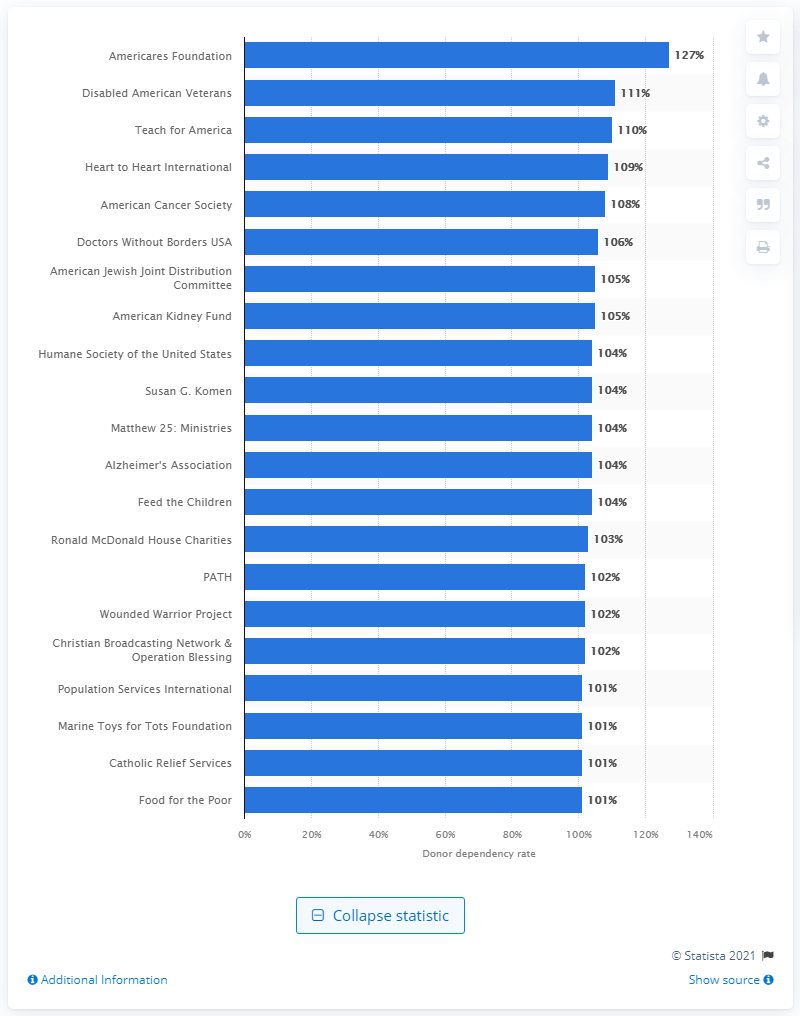Outline some significant characteristics in this image. Americares Foundation had the highest rate of dependency on its donors among all US charities. Americares Foundation's donor dependency rate in 2020 was 127%. 